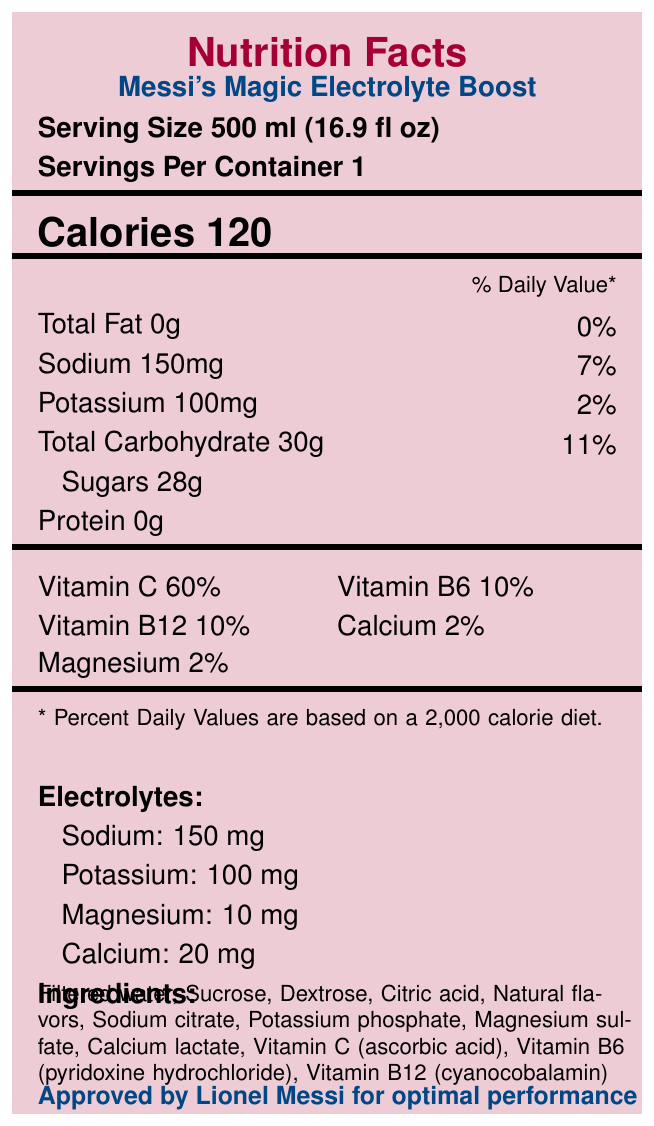What is the serving size of Messi's Magic Electrolyte Boost? The serving size is clearly stated on the label near the top as "Serving Size 500 ml (16.9 fl oz)".
Answer: 500 ml (16.9 fl oz) How many calories are in a serving of this sports drink? The label specifies "Calories 120" near the top of the document.
Answer: 120 calories How much sugar is in one serving? The amount of sugar is listed under "Sugars 28g" in the nutrients section.
Answer: 28g What are the key electrolytes found in Messi's Magic Electrolyte Boost? The electrolytes are listed explicitly in the section labeled "Electrolytes" as "Sodium: 150 mg", "Potassium: 100 mg", "Magnesium: 10 mg", and "Calcium: 20 mg".
Answer: Sodium, potassium, magnesium, calcium How many grams of total carbohydrate are there per serving? The total carbohydrate content is listed as "Total Carbohydrate 30g" in the nutrients section.
Answer: 30g Which vitamins are included in Messi's Magic Electrolyte Boost? A. Vitamin A, C, D B. Vitamin C, B6, B12 C. Vitamin E, K, B12 D. Vitamin D, A, E The vitamins listed in the document are "Vitamin C 60%", "Vitamin B6 10%", and "Vitamin B12 10%".
Answer: B. Vitamin C, B6, B12 What percentage of the daily value does calcium contribute? A. 2% B. 10% C. 30% D. 60% The label clearly states under vitamins and minerals that calcium contributes "Calcium 2%".
Answer: A. 2% Is the bottle made from recycled plastic? This information is stated in the "sustainability_note" section as "Bottle made from 100% recycled plastic".
Answer: Yes Summarize the main purpose of Messi's Magic Electrolyte Boost. The drink provides key electrolytes and vitamins and supports sustainability by using 100% recycled plastic bottles. It's promoted for use before, during, and after intense activities.
Answer: Messi's Magic Electrolyte Boost is a sports drink designed for rapid hydration, electrolyte replenishment, and energy boosting for optimal performance during football matches or training, endorsed by Lionel Messi. What is the specific contribution to the Leo Messi Foundation from sales of this product? The document notes in the "messi_foundation_contribution" section that "1% of sales donated to the Leo Messi Foundation".
Answer: 1% of sales What are the main ingredients in this sports drink? The ingredients are listed in the "Ingredients" section of the document.
Answer: Filtered water, sucrose, dextrose, citric acid, natural flavors, sodium citrate, potassium phosphate, magnesium sulfate, calcium lactate, vitamin C, vitamin B6, vitamin B12 What flavor is Messi's Magic Electrolyte Boost? The flavor is specified in the "flavor" section as "Citrus Tango".
Answer: Citrus Tango Under what circumstances is this drink recommended for consumption? The recommended usage is listed as "Drink before, during, and after intense football matches or training sessions".
Answer: Before, during, and after intense football matches or training sessions Who endorses this sports drink for optimal performance? The endorsement by Lionel Messi is noted at the end of the document as "Approved by Lionel Messi for optimal performance".
Answer: Lionel Messi What are the colors used in the design to represent FC Barcelona? The document references FC Barcelona with the colors "primary: Maroon, secondary: Blue".
Answer: Maroon and Blue Is there any mention of dietary fibers in the nutrition facts? The document does not list dietary fibers in the nutrition facts provided.
Answer: No How much magnesium is present per serving according to the electrolytes section? The electrolytes section provides this information, listing magnesium as "Magnesium: 10 mg".
Answer: 10 mg Is the recommended usage for this drink specific to any type of sport? The recommended usage section specifies usage for "intense football matches or training sessions", implying it is optimized for football.
Answer: Yes 